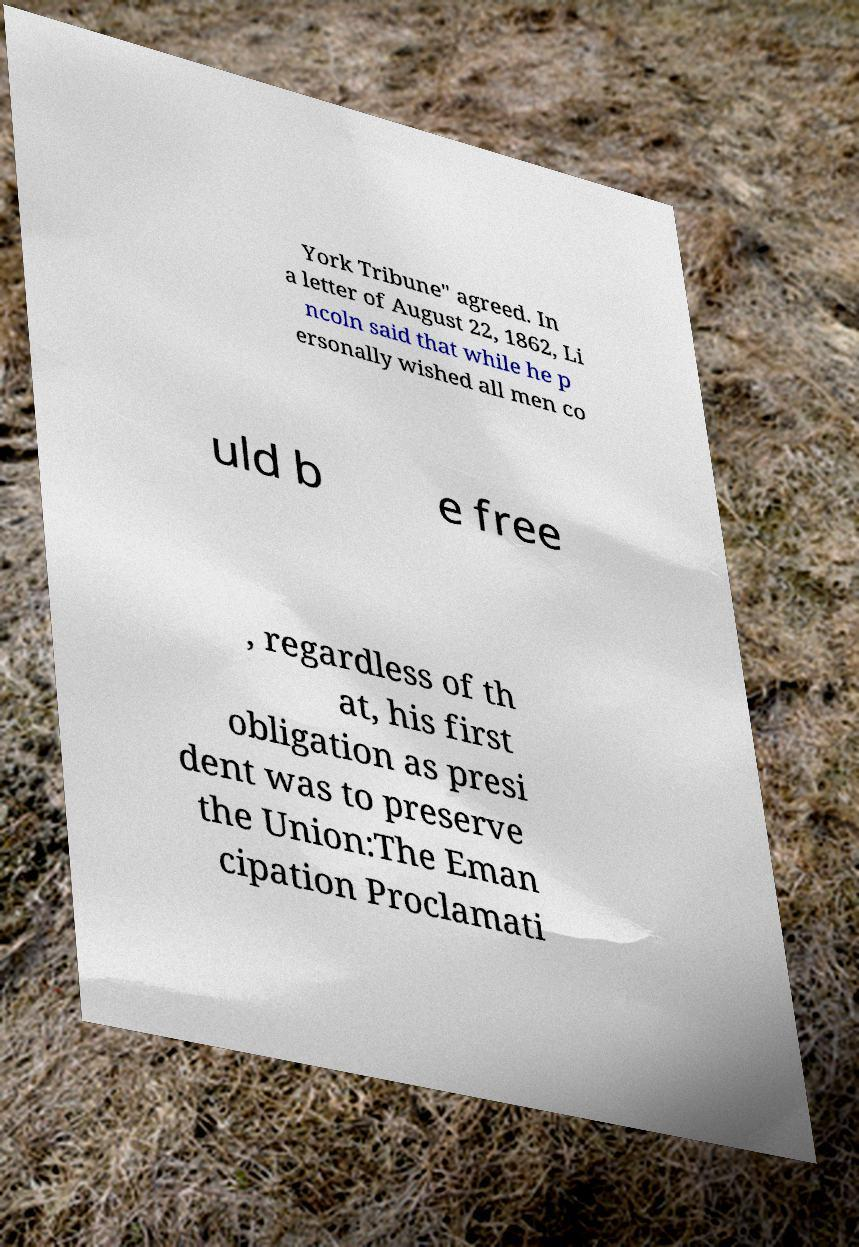Please read and relay the text visible in this image. What does it say? York Tribune" agreed. In a letter of August 22, 1862, Li ncoln said that while he p ersonally wished all men co uld b e free , regardless of th at, his first obligation as presi dent was to preserve the Union:The Eman cipation Proclamati 